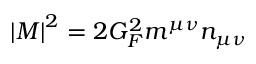<formula> <loc_0><loc_0><loc_500><loc_500>\left | M \right | ^ { 2 } = 2 G _ { F } ^ { 2 } m ^ { \mu \nu } n _ { \mu \nu }</formula> 